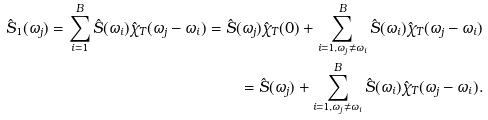<formula> <loc_0><loc_0><loc_500><loc_500>\hat { S } _ { 1 } ( \omega _ { j } ) = \sum _ { i = 1 } ^ { B } \hat { S } ( \omega _ { i } ) \hat { \chi } _ { T } ( \omega _ { j } - \omega _ { i } ) = \hat { S } ( \omega _ { j } ) \hat { \chi } _ { T } ( 0 ) + \sum _ { i = 1 , \omega _ { j } \neq \omega _ { i } } ^ { B } \hat { S } ( \omega _ { i } ) \hat { \chi } _ { T } ( \omega _ { j } - \omega _ { i } ) \\ = \hat { S } ( \omega _ { j } ) + \sum _ { i = 1 , \omega _ { j } \neq \omega _ { i } } ^ { B } \hat { S } ( \omega _ { i } ) \hat { \chi } _ { T } ( \omega _ { j } - \omega _ { i } ) .</formula> 